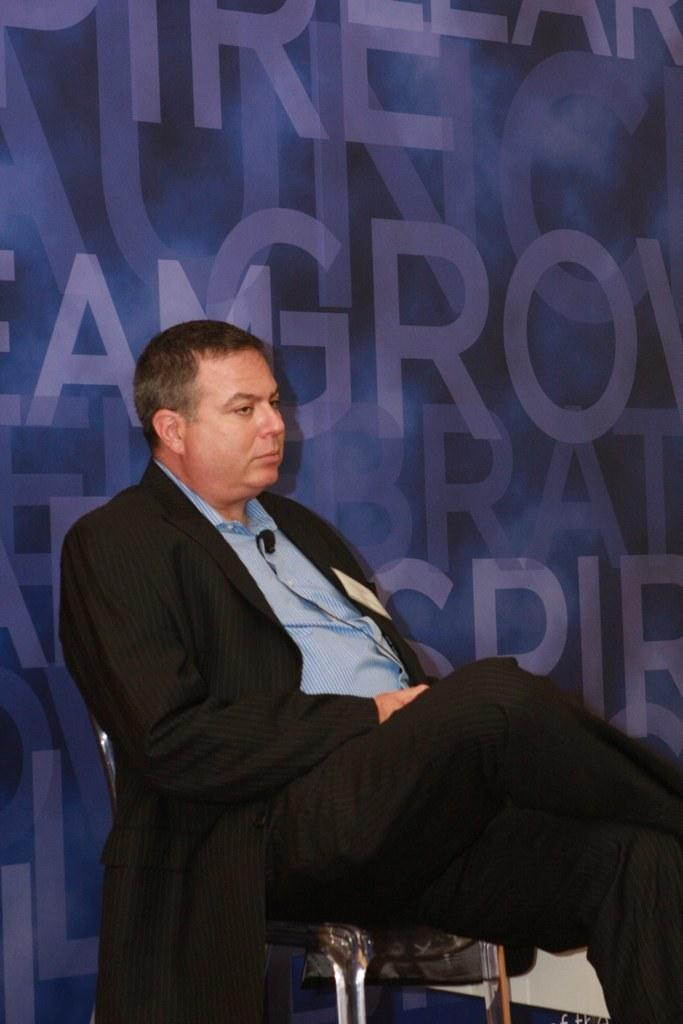Who is present in the image? There is a man in the picture. What is the man doing in the image? The man is sitting on a chair. What can be seen on the surface behind the man? There are alphabets on a surface behind the man. What hobbies does the man have, as indicated by the presence of a gun in the image? There is no gun present in the image, so we cannot determine the man's hobbies based on that. 